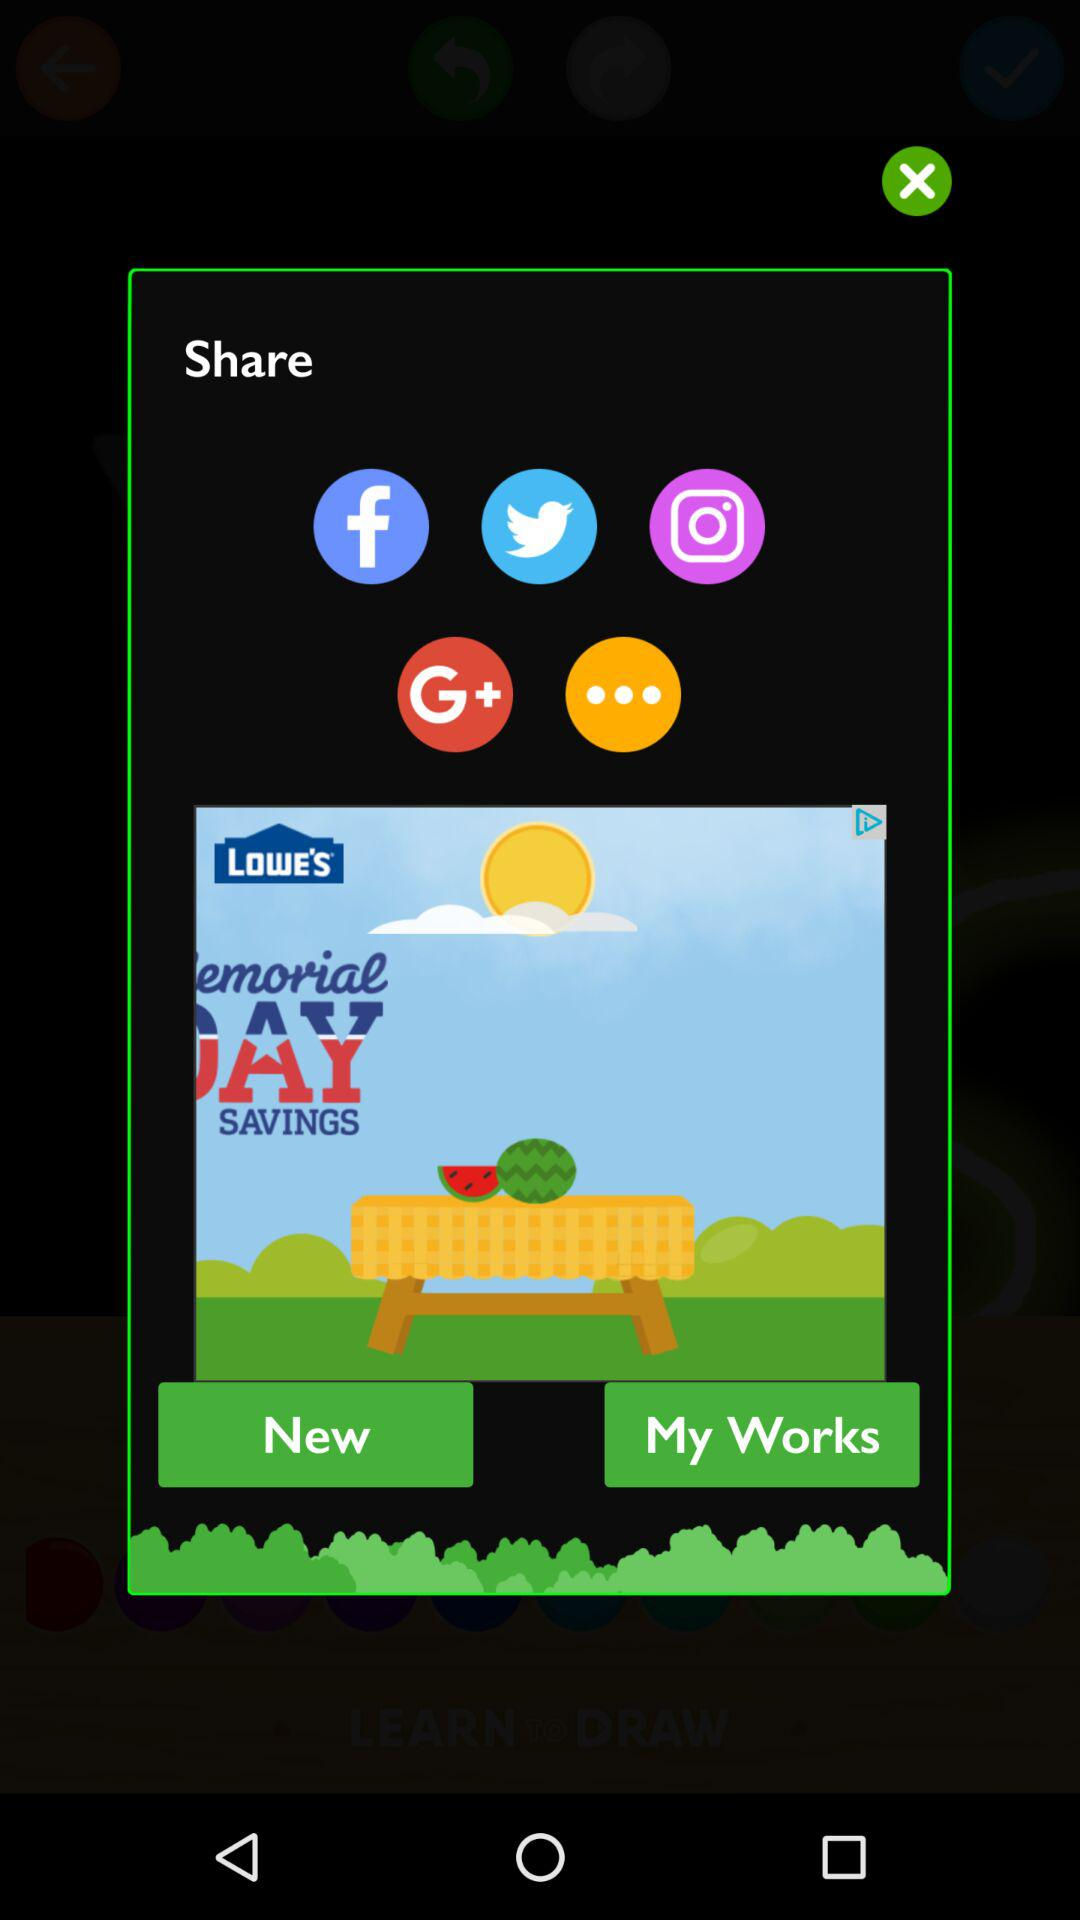Through which application can it be shared? It can be shared through "Facebook", "Twitter", "Instagram" and "Google+". 